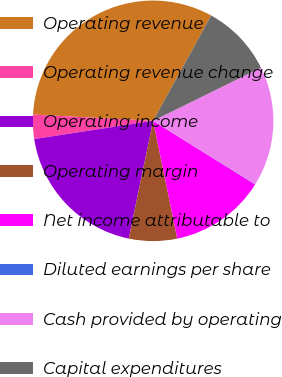Convert chart to OTSL. <chart><loc_0><loc_0><loc_500><loc_500><pie_chart><fcel>Operating revenue<fcel>Operating revenue change<fcel>Operating income<fcel>Operating margin<fcel>Net income attributable to<fcel>Diluted earnings per share<fcel>Cash provided by operating<fcel>Capital expenditures<nl><fcel>32.2%<fcel>3.25%<fcel>19.33%<fcel>6.47%<fcel>12.9%<fcel>0.04%<fcel>16.12%<fcel>9.69%<nl></chart> 